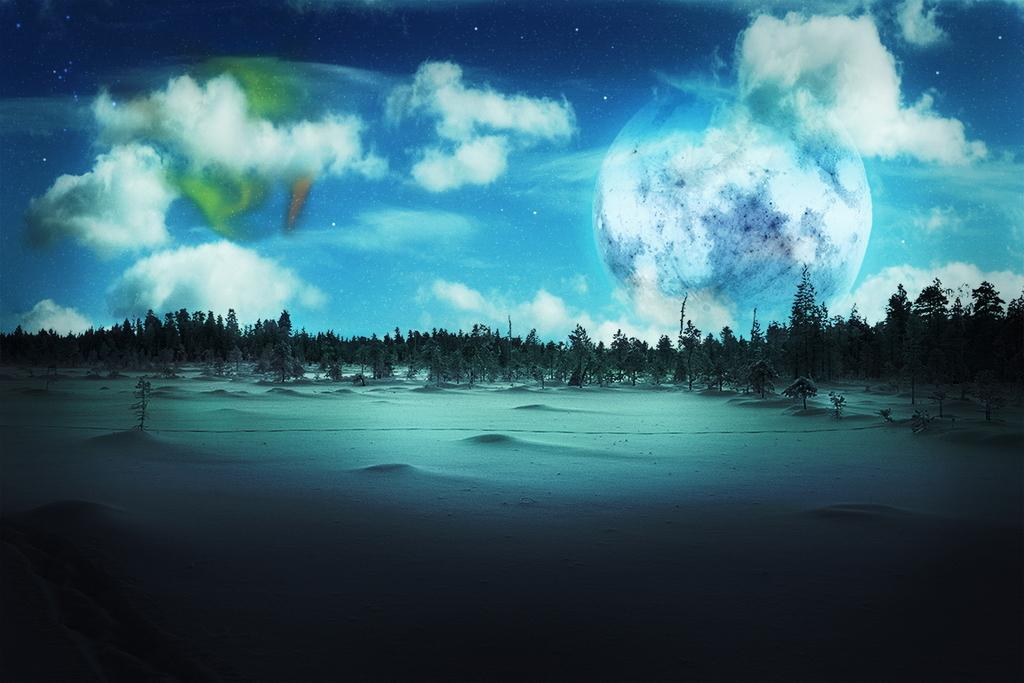What type of vegetation is present on the ground in the image? There are trees on the ground in the image. What is covering the ground in the image? A: There is snow on the ground in the image. How would you describe the sky in the image? The sky in the image is colorful and cloudy. What celestial bodies are visible in the sky in the image? The moon and stars are visible in the sky in the image. What is your father doing in the image? There is no person, including a father, present in the image. Why are the trees crying in the image? Trees do not have the ability to cry, and there is no indication of any emotional response in the image. 